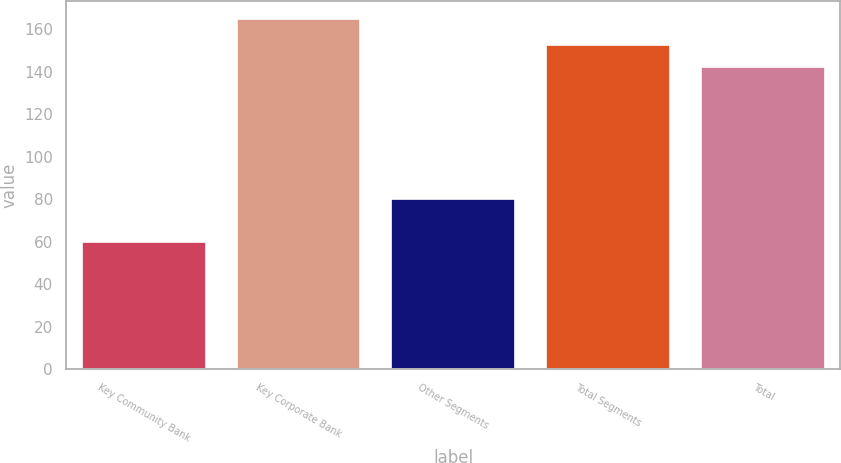Convert chart. <chart><loc_0><loc_0><loc_500><loc_500><bar_chart><fcel>Key Community Bank<fcel>Key Corporate Bank<fcel>Other Segments<fcel>Total Segments<fcel>Total<nl><fcel>60<fcel>165<fcel>80<fcel>152.5<fcel>142<nl></chart> 